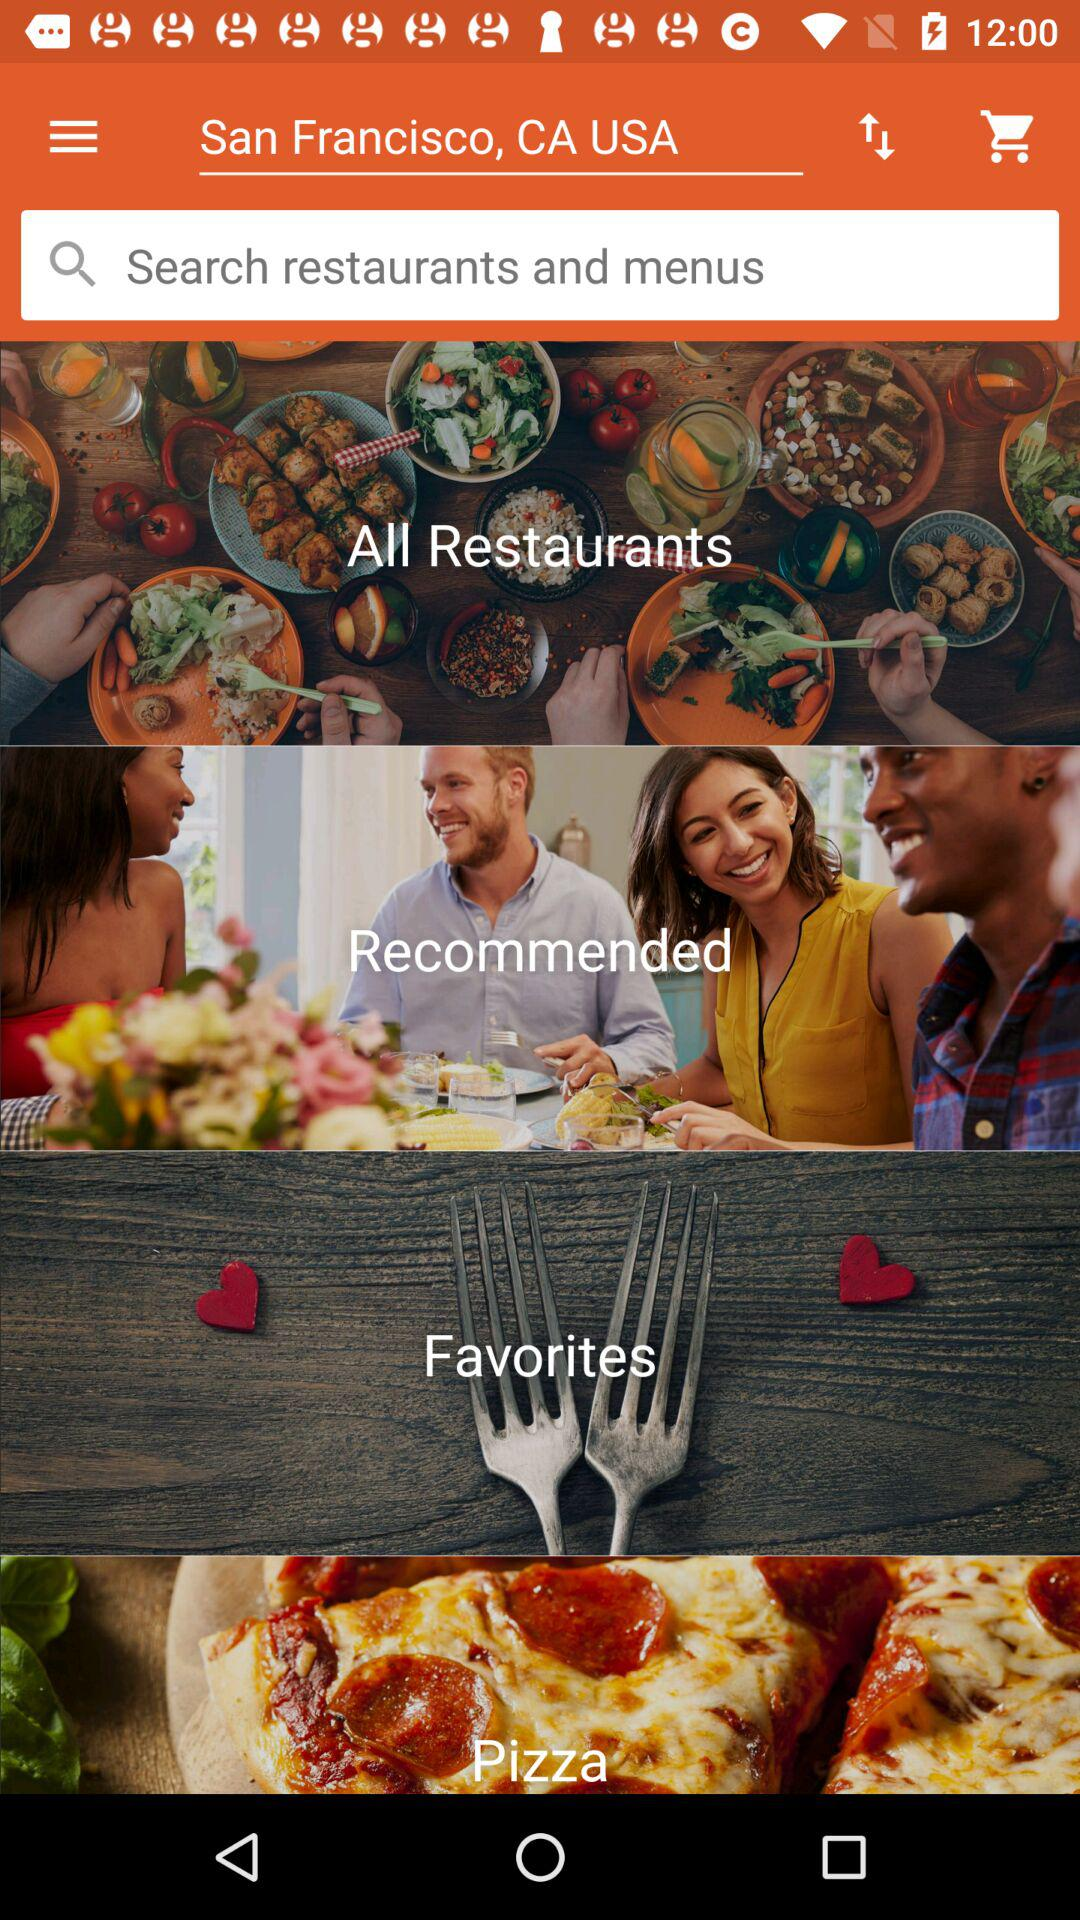Which restaurants are recommended?
When the provided information is insufficient, respond with <no answer>. <no answer> 